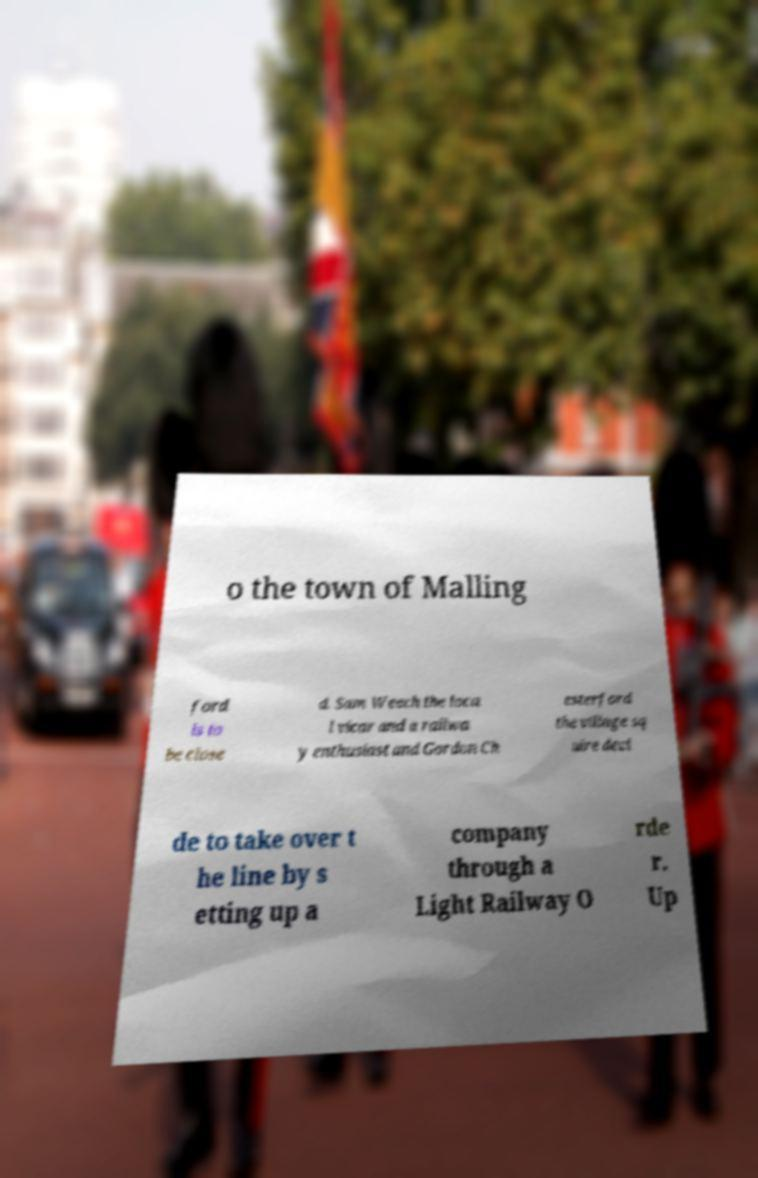Could you extract and type out the text from this image? o the town of Malling ford is to be close d. Sam Weech the loca l vicar and a railwa y enthusiast and Gordon Ch esterford the village sq uire deci de to take over t he line by s etting up a company through a Light Railway O rde r. Up 